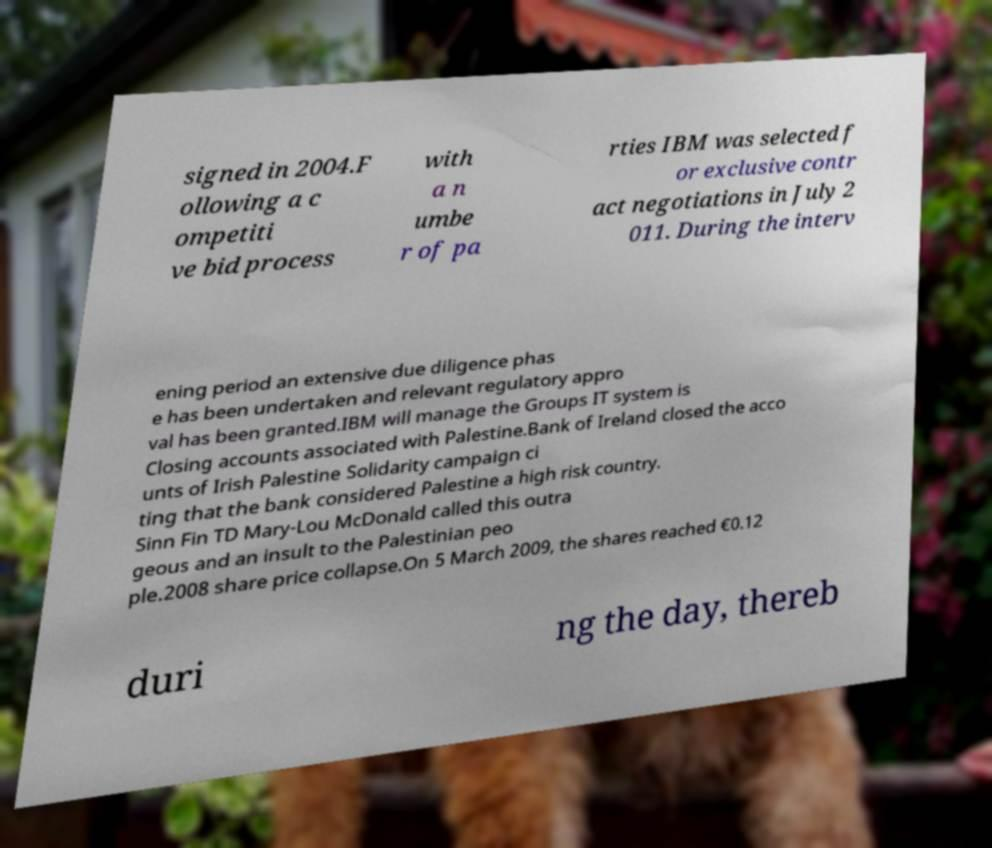There's text embedded in this image that I need extracted. Can you transcribe it verbatim? signed in 2004.F ollowing a c ompetiti ve bid process with a n umbe r of pa rties IBM was selected f or exclusive contr act negotiations in July 2 011. During the interv ening period an extensive due diligence phas e has been undertaken and relevant regulatory appro val has been granted.IBM will manage the Groups IT system is Closing accounts associated with Palestine.Bank of Ireland closed the acco unts of Irish Palestine Solidarity campaign ci ting that the bank considered Palestine a high risk country. Sinn Fin TD Mary-Lou McDonald called this outra geous and an insult to the Palestinian peo ple.2008 share price collapse.On 5 March 2009, the shares reached €0.12 duri ng the day, thereb 